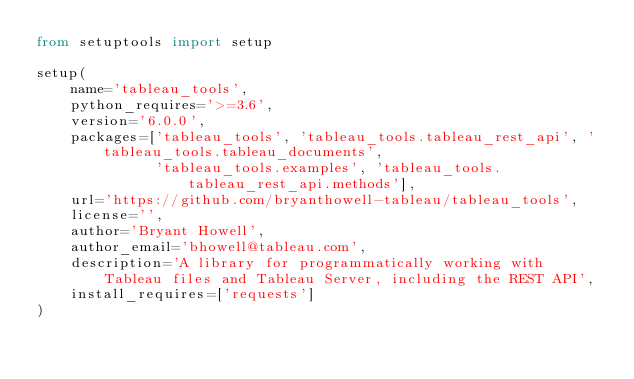Convert code to text. <code><loc_0><loc_0><loc_500><loc_500><_Python_>from setuptools import setup

setup(
    name='tableau_tools',
    python_requires='>=3.6',
    version='6.0.0',
    packages=['tableau_tools', 'tableau_tools.tableau_rest_api', 'tableau_tools.tableau_documents',
              'tableau_tools.examples', 'tableau_tools.tableau_rest_api.methods'],
    url='https://github.com/bryanthowell-tableau/tableau_tools',
    license='',
    author='Bryant Howell',
    author_email='bhowell@tableau.com',
    description='A library for programmatically working with Tableau files and Tableau Server, including the REST API',
    install_requires=['requests']
)
</code> 